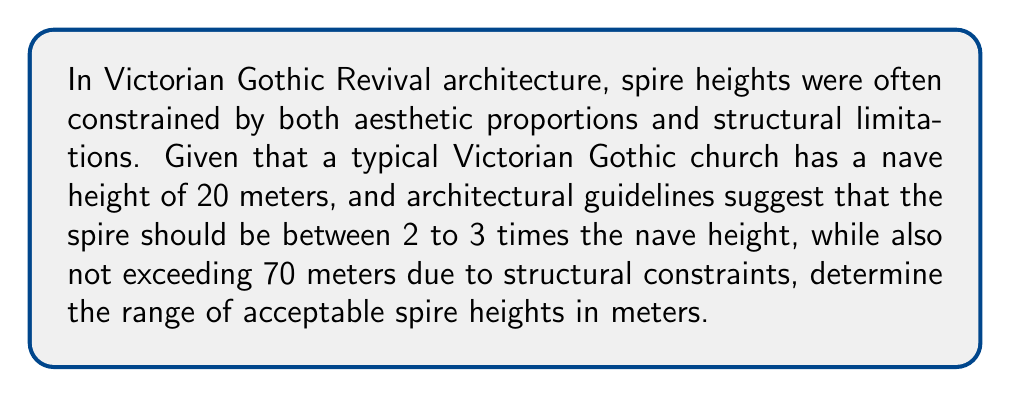Provide a solution to this math problem. Let's approach this step-by-step:

1) First, let's define our variables:
   Let $h$ be the height of the spire in meters.
   The nave height is given as 20 meters.

2) The aesthetic constraints state that the spire should be between 2 to 3 times the nave height:
   $2 \cdot 20 \leq h \leq 3 \cdot 20$
   $40 \leq h \leq 60$

3) The structural constraint states that the spire should not exceed 70 meters:
   $h \leq 70$

4) Combining these constraints, we get:
   $40 \leq h \leq 60$ (from aesthetic constraints)
   $h \leq 70$ (from structural constraints)

5) The lower bound is determined by the aesthetic constraint (40 meters), while the upper bound is determined by the stricter of the two upper limits (60 meters from aesthetics vs 70 meters from structure).

6) Therefore, the final inequality is:
   $40 \leq h \leq 60$

This means the spire height $h$ must be greater than or equal to 40 meters and less than or equal to 60 meters.
Answer: $40 \leq h \leq 60$, where $h$ is the spire height in meters. 